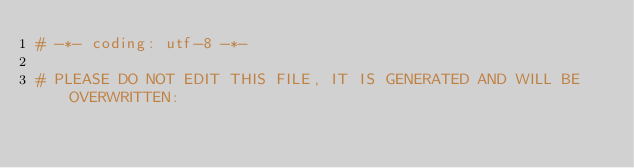<code> <loc_0><loc_0><loc_500><loc_500><_Python_># -*- coding: utf-8 -*-

# PLEASE DO NOT EDIT THIS FILE, IT IS GENERATED AND WILL BE OVERWRITTEN:</code> 